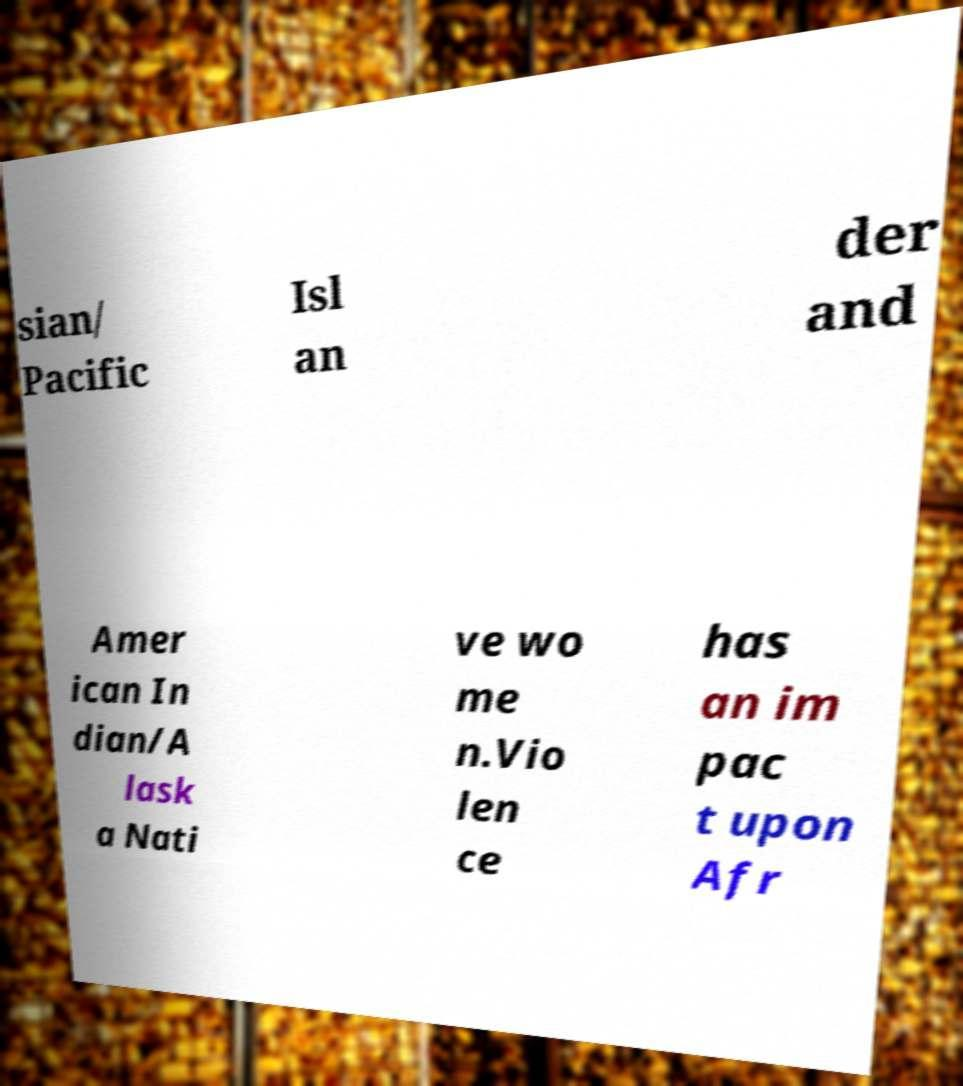There's text embedded in this image that I need extracted. Can you transcribe it verbatim? sian/ Pacific Isl an der and Amer ican In dian/A lask a Nati ve wo me n.Vio len ce has an im pac t upon Afr 